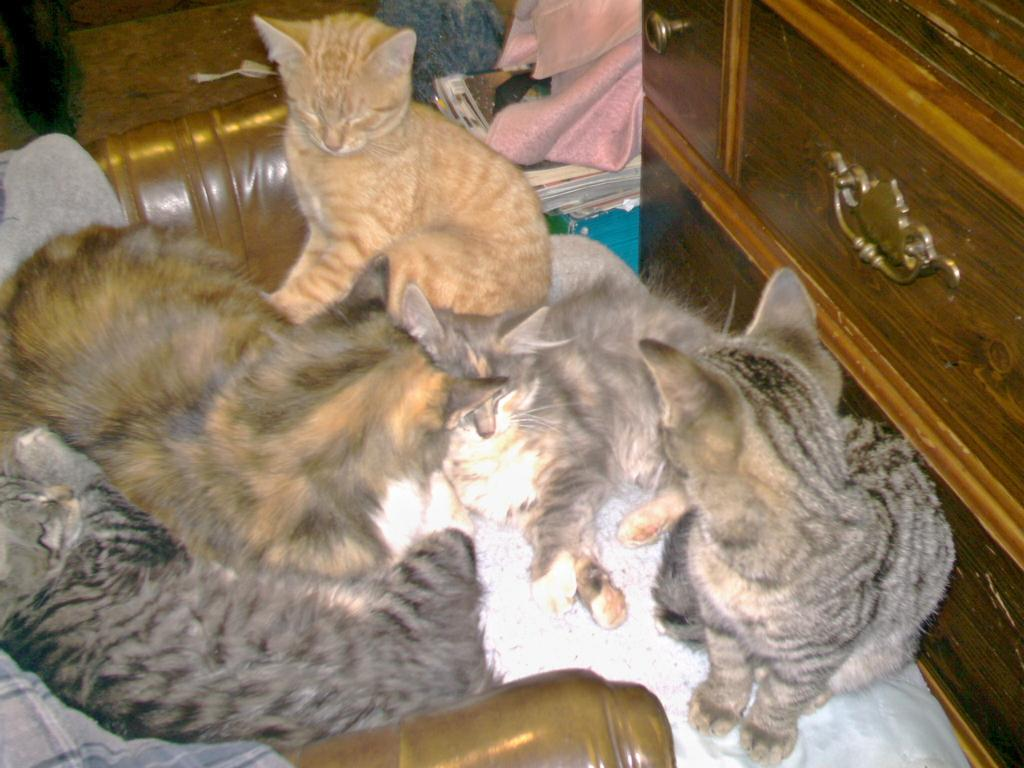What type of animals are in the picture? There are cats in the picture. What furniture piece is visible in the picture? There is a table drawer in the picture. Can you describe any other objects present in the picture? There are other objects present in the picture, but their specific details are not mentioned in the provided facts. What type of chicken is present in the picture? There is no chicken present in the picture; it features cats and a table drawer. What form does the power take in the picture? The provided facts do not mention any power source or form in the picture. 